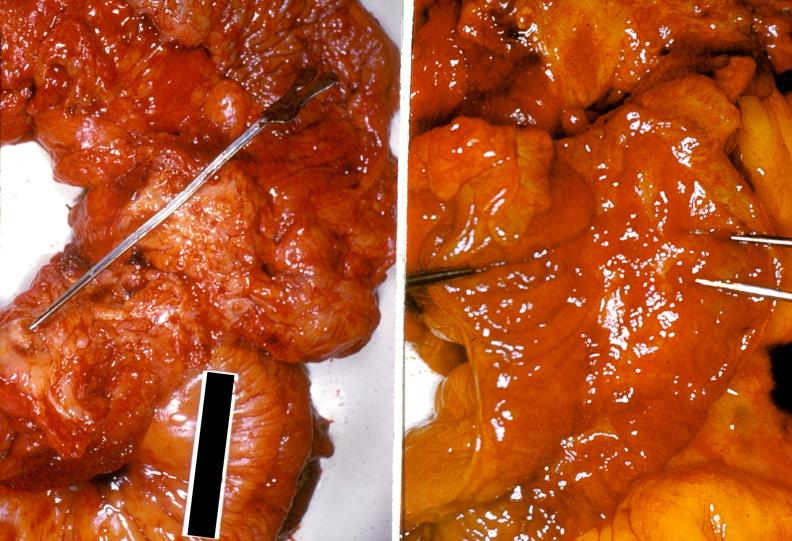s gastrointestinal present?
Answer the question using a single word or phrase. Yes 